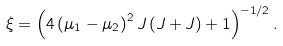<formula> <loc_0><loc_0><loc_500><loc_500>\xi = \left ( 4 \left ( \mu _ { 1 } - \mu _ { 2 } \right ) ^ { 2 } J \left ( J + J \right ) + 1 \right ) ^ { - 1 / 2 } .</formula> 